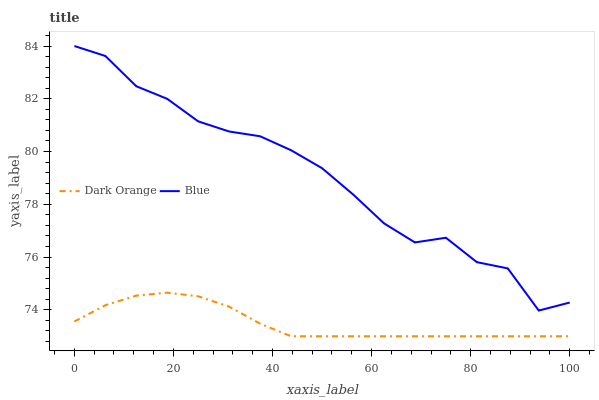Does Dark Orange have the minimum area under the curve?
Answer yes or no. Yes. Does Blue have the maximum area under the curve?
Answer yes or no. Yes. Does Dark Orange have the maximum area under the curve?
Answer yes or no. No. Is Dark Orange the smoothest?
Answer yes or no. Yes. Is Blue the roughest?
Answer yes or no. Yes. Is Dark Orange the roughest?
Answer yes or no. No. Does Blue have the highest value?
Answer yes or no. Yes. Does Dark Orange have the highest value?
Answer yes or no. No. Is Dark Orange less than Blue?
Answer yes or no. Yes. Is Blue greater than Dark Orange?
Answer yes or no. Yes. Does Dark Orange intersect Blue?
Answer yes or no. No. 